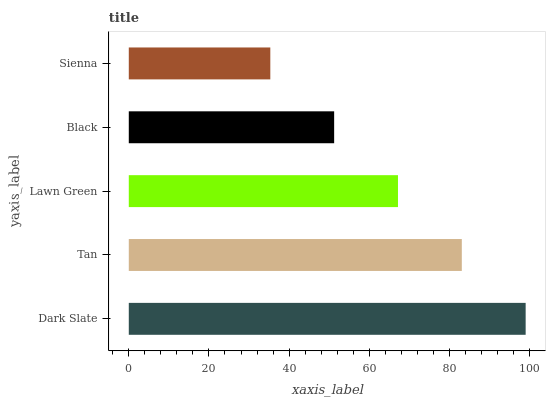Is Sienna the minimum?
Answer yes or no. Yes. Is Dark Slate the maximum?
Answer yes or no. Yes. Is Tan the minimum?
Answer yes or no. No. Is Tan the maximum?
Answer yes or no. No. Is Dark Slate greater than Tan?
Answer yes or no. Yes. Is Tan less than Dark Slate?
Answer yes or no. Yes. Is Tan greater than Dark Slate?
Answer yes or no. No. Is Dark Slate less than Tan?
Answer yes or no. No. Is Lawn Green the high median?
Answer yes or no. Yes. Is Lawn Green the low median?
Answer yes or no. Yes. Is Black the high median?
Answer yes or no. No. Is Dark Slate the low median?
Answer yes or no. No. 